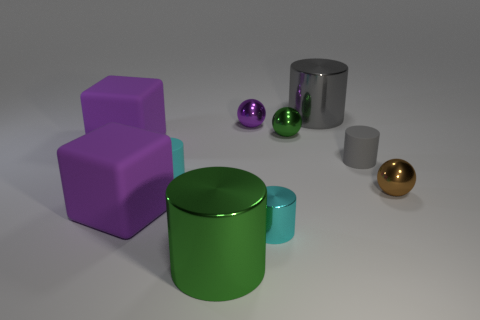Subtract 2 cylinders. How many cylinders are left? 3 Subtract all gray cylinders. How many cylinders are left? 3 Subtract all green shiny cylinders. How many cylinders are left? 4 Subtract all purple cylinders. Subtract all yellow cubes. How many cylinders are left? 5 Subtract all spheres. How many objects are left? 7 Add 8 green metallic balls. How many green metallic balls are left? 9 Add 6 large cyan blocks. How many large cyan blocks exist? 6 Subtract 1 green cylinders. How many objects are left? 9 Subtract all large gray metallic things. Subtract all tiny metal balls. How many objects are left? 6 